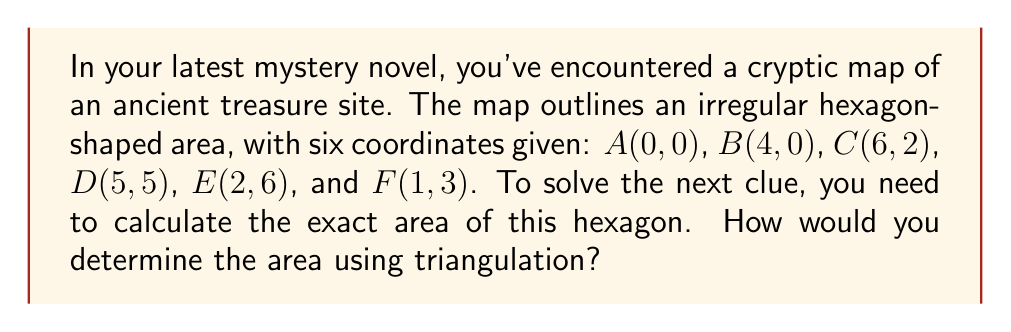Teach me how to tackle this problem. To solve this problem, we'll use the triangulation method:

1) First, divide the hexagon into four triangles: ABC, ACD, ADE, and AEF.

2) We can calculate the area of each triangle using the formula:
   $$Area = \frac{1}{2}|x_1(y_2 - y_3) + x_2(y_3 - y_1) + x_3(y_1 - y_2)|$$

3) For triangle ABC:
   $$Area_{ABC} = \frac{1}{2}|0(0 - 2) + 4(2 - 0) + 6(0 - 0)| = 4$$

4) For triangle ACD:
   $$Area_{ACD} = \frac{1}{2}|0(0 - 5) + 6(5 - 0) + 5(0 - 0)| = 15$$

5) For triangle ADE:
   $$Area_{ADE} = \frac{1}{2}|0(6 - 5) + 5(5 - 6) + 2(6 - 5)| = 5.5$$

6) For triangle AEF:
   $$Area_{AEF} = \frac{1}{2}|0(6 - 3) + 2(3 - 6) + 1(6 - 6)| = 3$$

7) The total area is the sum of these four triangles:
   $$Total Area = 4 + 15 + 5.5 + 3 = 27.5$$

[asy]
unitsize(20);
pair A=(0,0), B=(4,0), C=(6,2), D=(5,5), E=(2,6), F=(1,3);
draw(A--B--C--D--E--F--cycle);
draw(A--C--E);
label("A", A, SW);
label("B", B, S);
label("C", C, SE);
label("D", D, E);
label("E", E, N);
label("F", F, W);
[/asy]
Answer: 27.5 square units 